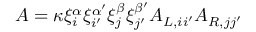<formula> <loc_0><loc_0><loc_500><loc_500>A = \kappa \xi _ { i } ^ { \alpha } \xi _ { i ^ { \prime } } ^ { \alpha ^ { \prime } } \xi _ { j } ^ { \beta } \xi _ { j ^ { \prime } } ^ { \beta ^ { \prime } } A _ { L , i i ^ { \prime } } A _ { R , j j ^ { \prime } }</formula> 